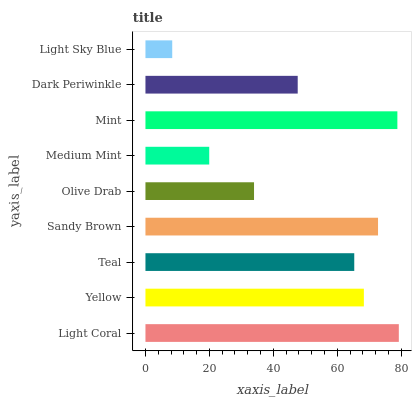Is Light Sky Blue the minimum?
Answer yes or no. Yes. Is Light Coral the maximum?
Answer yes or no. Yes. Is Yellow the minimum?
Answer yes or no. No. Is Yellow the maximum?
Answer yes or no. No. Is Light Coral greater than Yellow?
Answer yes or no. Yes. Is Yellow less than Light Coral?
Answer yes or no. Yes. Is Yellow greater than Light Coral?
Answer yes or no. No. Is Light Coral less than Yellow?
Answer yes or no. No. Is Teal the high median?
Answer yes or no. Yes. Is Teal the low median?
Answer yes or no. Yes. Is Yellow the high median?
Answer yes or no. No. Is Mint the low median?
Answer yes or no. No. 